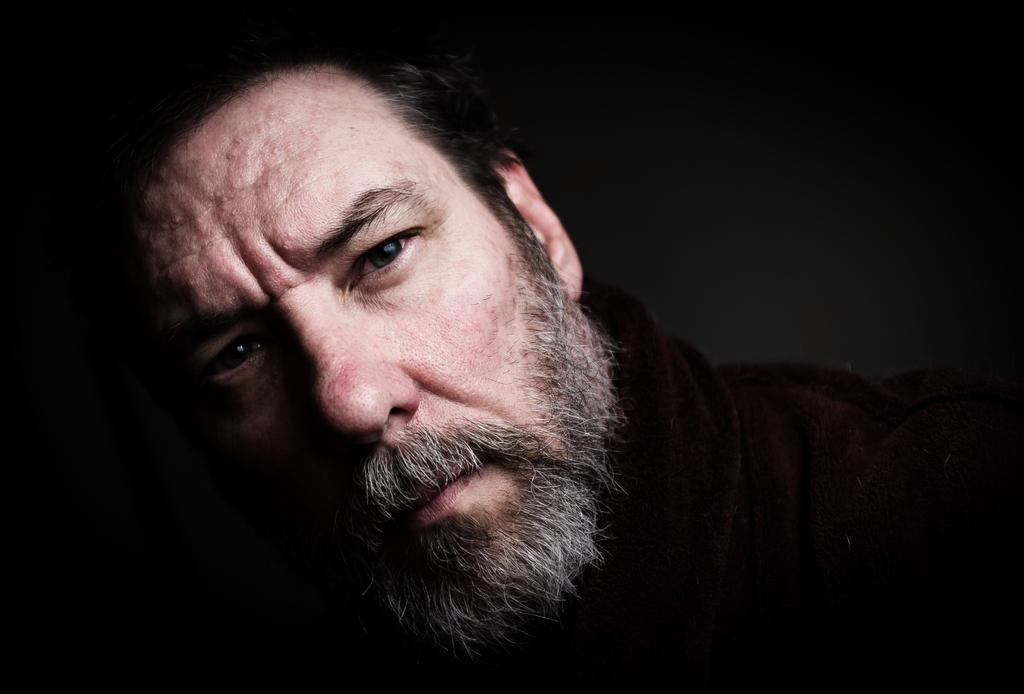Who or what is the main subject in the image? There is a person in the image. What can be seen behind the person in the image? The background of the image is black in color. What type of farm animals can be seen in the image? There are no farm animals present in the image. What color is the street in the image? There is no street present in the image. 